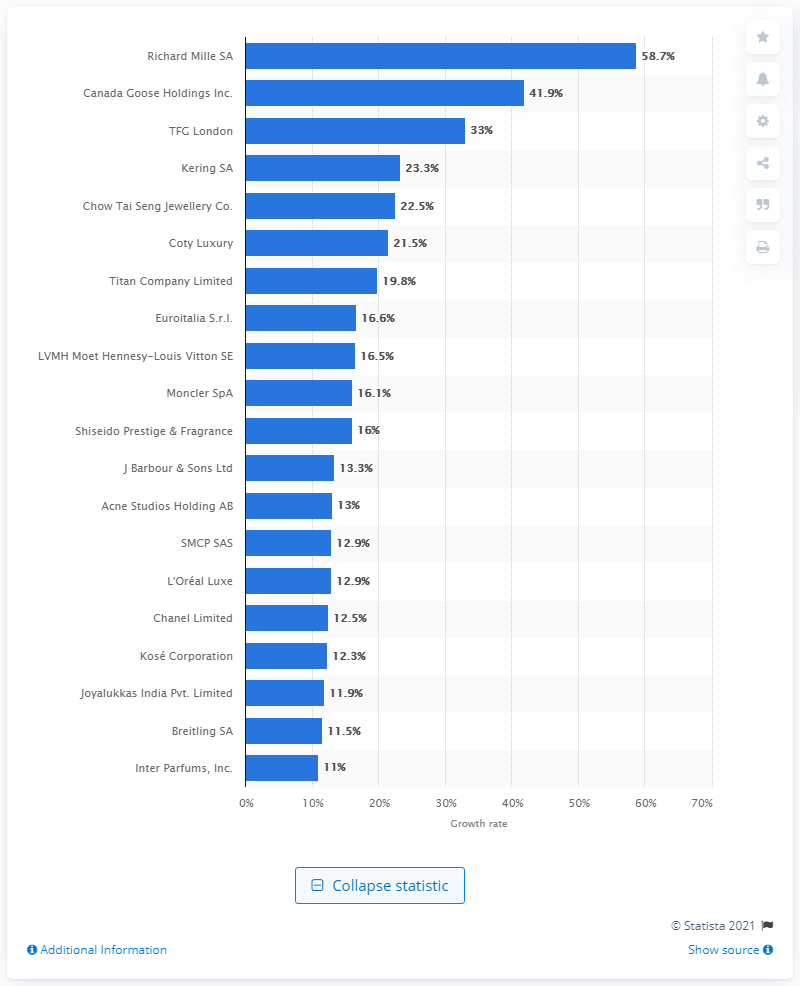Draw attention to some important aspects in this diagram. Richard Mille SA's Compound Annual Growth Rate (CAGR) between 2016 and 2019 was 58.7%. According to available data, Richard Mille SA was the fastest growing luxury goods firm between 2016 and 2019. 